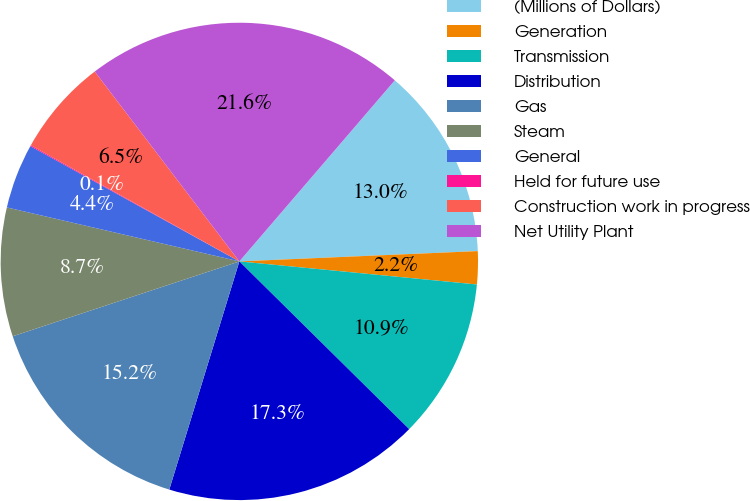<chart> <loc_0><loc_0><loc_500><loc_500><pie_chart><fcel>(Millions of Dollars)<fcel>Generation<fcel>Transmission<fcel>Distribution<fcel>Gas<fcel>Steam<fcel>General<fcel>Held for future use<fcel>Construction work in progress<fcel>Net Utility Plant<nl><fcel>13.02%<fcel>2.23%<fcel>10.86%<fcel>17.34%<fcel>15.18%<fcel>8.71%<fcel>4.39%<fcel>0.07%<fcel>6.55%<fcel>21.65%<nl></chart> 